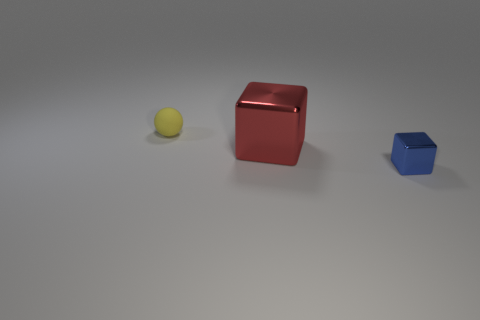Add 1 small purple cylinders. How many objects exist? 4 Subtract all spheres. How many objects are left? 2 Add 2 tiny metal blocks. How many tiny metal blocks exist? 3 Subtract 0 brown balls. How many objects are left? 3 Subtract all gray metallic blocks. Subtract all small yellow matte balls. How many objects are left? 2 Add 3 matte things. How many matte things are left? 4 